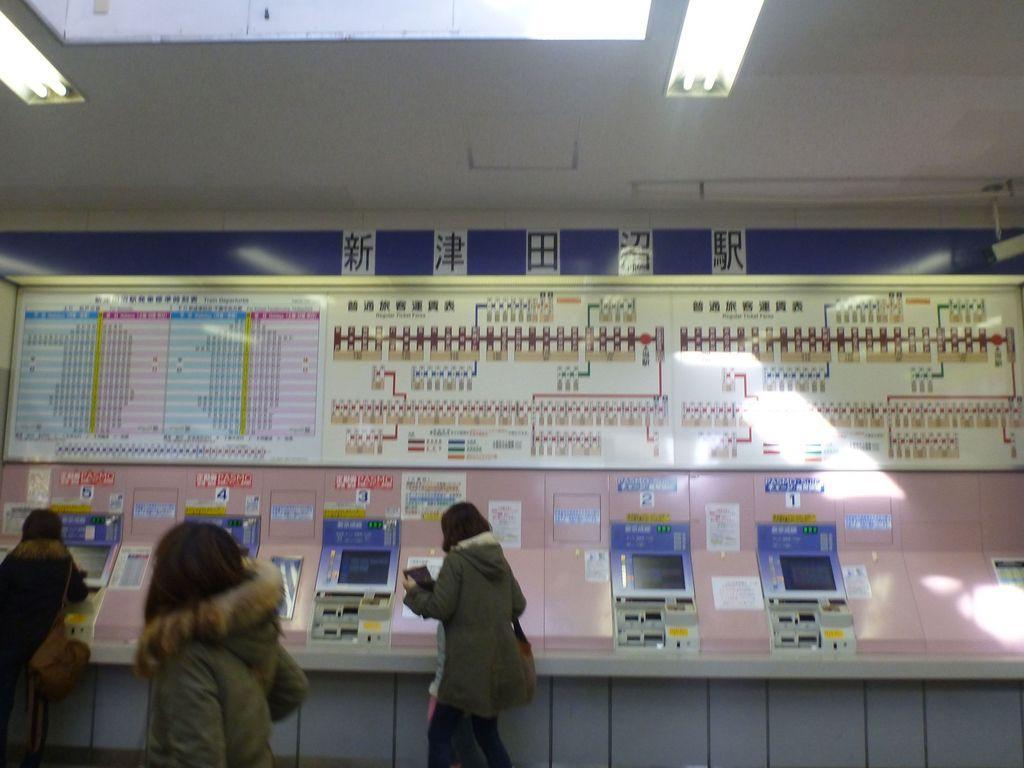Could you give a brief overview of what you see in this image? In this image we can see some people standing. One woman is holding an object in her hand. In the background, we can see some machines placed on the surface and a board with some text. At the top of the image we can see some lights on the roof. 